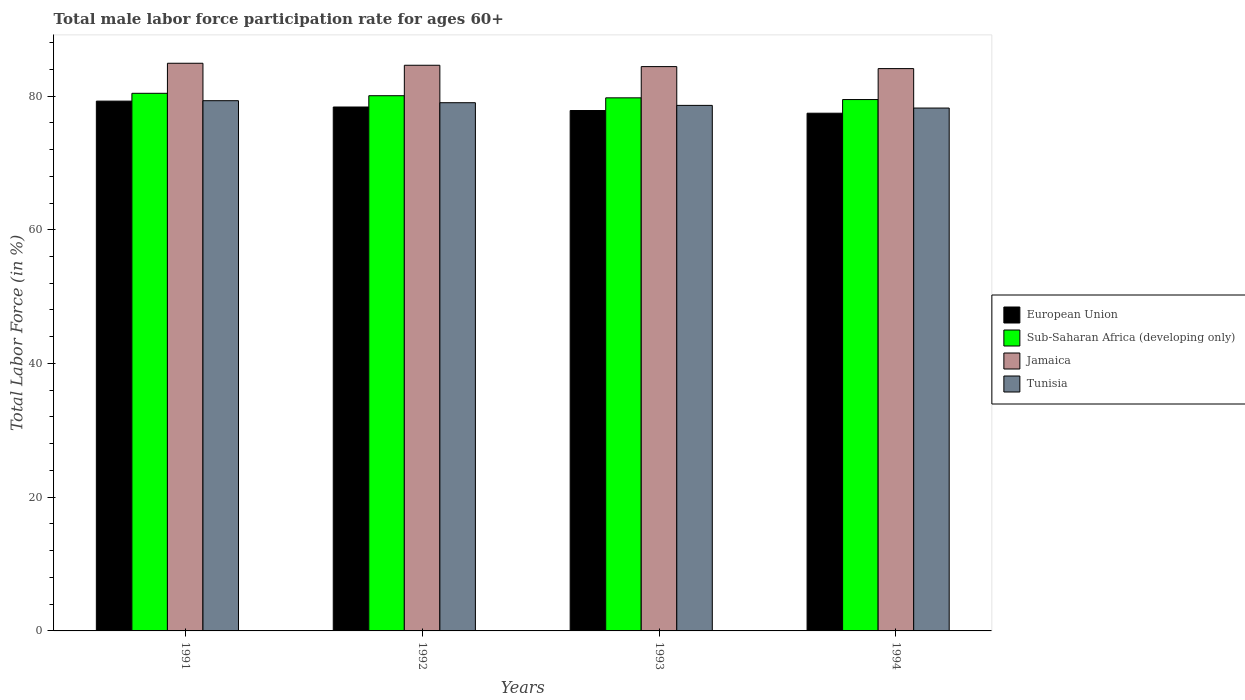How many different coloured bars are there?
Give a very brief answer. 4. Are the number of bars per tick equal to the number of legend labels?
Your answer should be very brief. Yes. How many bars are there on the 1st tick from the left?
Offer a very short reply. 4. How many bars are there on the 1st tick from the right?
Your answer should be compact. 4. What is the male labor force participation rate in Tunisia in 1994?
Give a very brief answer. 78.2. Across all years, what is the maximum male labor force participation rate in Jamaica?
Ensure brevity in your answer.  84.9. Across all years, what is the minimum male labor force participation rate in Jamaica?
Offer a very short reply. 84.1. What is the total male labor force participation rate in European Union in the graph?
Your answer should be compact. 312.85. What is the difference between the male labor force participation rate in Sub-Saharan Africa (developing only) in 1991 and that in 1992?
Offer a terse response. 0.36. What is the difference between the male labor force participation rate in Jamaica in 1993 and the male labor force participation rate in Sub-Saharan Africa (developing only) in 1991?
Your response must be concise. 3.99. What is the average male labor force participation rate in Sub-Saharan Africa (developing only) per year?
Provide a short and direct response. 79.91. In the year 1991, what is the difference between the male labor force participation rate in Tunisia and male labor force participation rate in European Union?
Make the answer very short. 0.06. What is the ratio of the male labor force participation rate in Sub-Saharan Africa (developing only) in 1992 to that in 1993?
Keep it short and to the point. 1. What is the difference between the highest and the second highest male labor force participation rate in Sub-Saharan Africa (developing only)?
Give a very brief answer. 0.36. What is the difference between the highest and the lowest male labor force participation rate in European Union?
Offer a terse response. 1.81. In how many years, is the male labor force participation rate in Tunisia greater than the average male labor force participation rate in Tunisia taken over all years?
Give a very brief answer. 2. What does the 1st bar from the left in 1993 represents?
Your response must be concise. European Union. What does the 1st bar from the right in 1994 represents?
Provide a succinct answer. Tunisia. Is it the case that in every year, the sum of the male labor force participation rate in Tunisia and male labor force participation rate in Jamaica is greater than the male labor force participation rate in European Union?
Provide a succinct answer. Yes. How many bars are there?
Keep it short and to the point. 16. Are all the bars in the graph horizontal?
Your answer should be compact. No. How many years are there in the graph?
Give a very brief answer. 4. Are the values on the major ticks of Y-axis written in scientific E-notation?
Give a very brief answer. No. Does the graph contain any zero values?
Your response must be concise. No. Does the graph contain grids?
Your answer should be compact. No. How many legend labels are there?
Your response must be concise. 4. What is the title of the graph?
Offer a terse response. Total male labor force participation rate for ages 60+. Does "Pacific island small states" appear as one of the legend labels in the graph?
Ensure brevity in your answer.  No. What is the Total Labor Force (in %) of European Union in 1991?
Offer a very short reply. 79.24. What is the Total Labor Force (in %) of Sub-Saharan Africa (developing only) in 1991?
Your answer should be compact. 80.41. What is the Total Labor Force (in %) in Jamaica in 1991?
Keep it short and to the point. 84.9. What is the Total Labor Force (in %) of Tunisia in 1991?
Give a very brief answer. 79.3. What is the Total Labor Force (in %) in European Union in 1992?
Offer a very short reply. 78.36. What is the Total Labor Force (in %) of Sub-Saharan Africa (developing only) in 1992?
Your answer should be compact. 80.05. What is the Total Labor Force (in %) of Jamaica in 1992?
Provide a short and direct response. 84.6. What is the Total Labor Force (in %) in Tunisia in 1992?
Offer a terse response. 79. What is the Total Labor Force (in %) of European Union in 1993?
Give a very brief answer. 77.83. What is the Total Labor Force (in %) in Sub-Saharan Africa (developing only) in 1993?
Make the answer very short. 79.73. What is the Total Labor Force (in %) in Jamaica in 1993?
Your response must be concise. 84.4. What is the Total Labor Force (in %) of Tunisia in 1993?
Provide a short and direct response. 78.6. What is the Total Labor Force (in %) in European Union in 1994?
Offer a terse response. 77.43. What is the Total Labor Force (in %) in Sub-Saharan Africa (developing only) in 1994?
Ensure brevity in your answer.  79.47. What is the Total Labor Force (in %) in Jamaica in 1994?
Your response must be concise. 84.1. What is the Total Labor Force (in %) in Tunisia in 1994?
Offer a very short reply. 78.2. Across all years, what is the maximum Total Labor Force (in %) of European Union?
Provide a succinct answer. 79.24. Across all years, what is the maximum Total Labor Force (in %) of Sub-Saharan Africa (developing only)?
Make the answer very short. 80.41. Across all years, what is the maximum Total Labor Force (in %) in Jamaica?
Keep it short and to the point. 84.9. Across all years, what is the maximum Total Labor Force (in %) of Tunisia?
Provide a succinct answer. 79.3. Across all years, what is the minimum Total Labor Force (in %) of European Union?
Make the answer very short. 77.43. Across all years, what is the minimum Total Labor Force (in %) in Sub-Saharan Africa (developing only)?
Your answer should be compact. 79.47. Across all years, what is the minimum Total Labor Force (in %) in Jamaica?
Provide a short and direct response. 84.1. Across all years, what is the minimum Total Labor Force (in %) of Tunisia?
Provide a succinct answer. 78.2. What is the total Total Labor Force (in %) of European Union in the graph?
Your answer should be very brief. 312.85. What is the total Total Labor Force (in %) of Sub-Saharan Africa (developing only) in the graph?
Ensure brevity in your answer.  319.65. What is the total Total Labor Force (in %) of Jamaica in the graph?
Make the answer very short. 338. What is the total Total Labor Force (in %) of Tunisia in the graph?
Your answer should be compact. 315.1. What is the difference between the Total Labor Force (in %) of European Union in 1991 and that in 1992?
Your answer should be very brief. 0.88. What is the difference between the Total Labor Force (in %) in Sub-Saharan Africa (developing only) in 1991 and that in 1992?
Give a very brief answer. 0.36. What is the difference between the Total Labor Force (in %) of Jamaica in 1991 and that in 1992?
Offer a very short reply. 0.3. What is the difference between the Total Labor Force (in %) of Tunisia in 1991 and that in 1992?
Offer a terse response. 0.3. What is the difference between the Total Labor Force (in %) of European Union in 1991 and that in 1993?
Your response must be concise. 1.41. What is the difference between the Total Labor Force (in %) of Sub-Saharan Africa (developing only) in 1991 and that in 1993?
Offer a very short reply. 0.68. What is the difference between the Total Labor Force (in %) in Jamaica in 1991 and that in 1993?
Ensure brevity in your answer.  0.5. What is the difference between the Total Labor Force (in %) of Tunisia in 1991 and that in 1993?
Give a very brief answer. 0.7. What is the difference between the Total Labor Force (in %) in European Union in 1991 and that in 1994?
Give a very brief answer. 1.81. What is the difference between the Total Labor Force (in %) in Sub-Saharan Africa (developing only) in 1991 and that in 1994?
Your response must be concise. 0.93. What is the difference between the Total Labor Force (in %) in Jamaica in 1991 and that in 1994?
Your answer should be compact. 0.8. What is the difference between the Total Labor Force (in %) in Tunisia in 1991 and that in 1994?
Your answer should be very brief. 1.1. What is the difference between the Total Labor Force (in %) of European Union in 1992 and that in 1993?
Provide a succinct answer. 0.53. What is the difference between the Total Labor Force (in %) of Sub-Saharan Africa (developing only) in 1992 and that in 1993?
Make the answer very short. 0.32. What is the difference between the Total Labor Force (in %) of Tunisia in 1992 and that in 1993?
Ensure brevity in your answer.  0.4. What is the difference between the Total Labor Force (in %) of European Union in 1992 and that in 1994?
Your answer should be compact. 0.93. What is the difference between the Total Labor Force (in %) in Sub-Saharan Africa (developing only) in 1992 and that in 1994?
Make the answer very short. 0.58. What is the difference between the Total Labor Force (in %) in Jamaica in 1992 and that in 1994?
Provide a short and direct response. 0.5. What is the difference between the Total Labor Force (in %) in European Union in 1993 and that in 1994?
Provide a succinct answer. 0.4. What is the difference between the Total Labor Force (in %) of Sub-Saharan Africa (developing only) in 1993 and that in 1994?
Offer a very short reply. 0.26. What is the difference between the Total Labor Force (in %) in Jamaica in 1993 and that in 1994?
Your response must be concise. 0.3. What is the difference between the Total Labor Force (in %) of Tunisia in 1993 and that in 1994?
Offer a terse response. 0.4. What is the difference between the Total Labor Force (in %) in European Union in 1991 and the Total Labor Force (in %) in Sub-Saharan Africa (developing only) in 1992?
Your response must be concise. -0.81. What is the difference between the Total Labor Force (in %) in European Union in 1991 and the Total Labor Force (in %) in Jamaica in 1992?
Keep it short and to the point. -5.36. What is the difference between the Total Labor Force (in %) of European Union in 1991 and the Total Labor Force (in %) of Tunisia in 1992?
Your answer should be very brief. 0.24. What is the difference between the Total Labor Force (in %) of Sub-Saharan Africa (developing only) in 1991 and the Total Labor Force (in %) of Jamaica in 1992?
Ensure brevity in your answer.  -4.19. What is the difference between the Total Labor Force (in %) in Sub-Saharan Africa (developing only) in 1991 and the Total Labor Force (in %) in Tunisia in 1992?
Your answer should be compact. 1.41. What is the difference between the Total Labor Force (in %) of European Union in 1991 and the Total Labor Force (in %) of Sub-Saharan Africa (developing only) in 1993?
Provide a succinct answer. -0.49. What is the difference between the Total Labor Force (in %) of European Union in 1991 and the Total Labor Force (in %) of Jamaica in 1993?
Offer a terse response. -5.16. What is the difference between the Total Labor Force (in %) of European Union in 1991 and the Total Labor Force (in %) of Tunisia in 1993?
Make the answer very short. 0.64. What is the difference between the Total Labor Force (in %) of Sub-Saharan Africa (developing only) in 1991 and the Total Labor Force (in %) of Jamaica in 1993?
Make the answer very short. -3.99. What is the difference between the Total Labor Force (in %) in Sub-Saharan Africa (developing only) in 1991 and the Total Labor Force (in %) in Tunisia in 1993?
Offer a terse response. 1.81. What is the difference between the Total Labor Force (in %) of European Union in 1991 and the Total Labor Force (in %) of Sub-Saharan Africa (developing only) in 1994?
Make the answer very short. -0.23. What is the difference between the Total Labor Force (in %) of European Union in 1991 and the Total Labor Force (in %) of Jamaica in 1994?
Your response must be concise. -4.86. What is the difference between the Total Labor Force (in %) of European Union in 1991 and the Total Labor Force (in %) of Tunisia in 1994?
Provide a short and direct response. 1.04. What is the difference between the Total Labor Force (in %) in Sub-Saharan Africa (developing only) in 1991 and the Total Labor Force (in %) in Jamaica in 1994?
Your answer should be compact. -3.69. What is the difference between the Total Labor Force (in %) in Sub-Saharan Africa (developing only) in 1991 and the Total Labor Force (in %) in Tunisia in 1994?
Your answer should be compact. 2.21. What is the difference between the Total Labor Force (in %) of European Union in 1992 and the Total Labor Force (in %) of Sub-Saharan Africa (developing only) in 1993?
Give a very brief answer. -1.37. What is the difference between the Total Labor Force (in %) in European Union in 1992 and the Total Labor Force (in %) in Jamaica in 1993?
Offer a very short reply. -6.04. What is the difference between the Total Labor Force (in %) in European Union in 1992 and the Total Labor Force (in %) in Tunisia in 1993?
Your response must be concise. -0.24. What is the difference between the Total Labor Force (in %) of Sub-Saharan Africa (developing only) in 1992 and the Total Labor Force (in %) of Jamaica in 1993?
Your answer should be very brief. -4.35. What is the difference between the Total Labor Force (in %) in Sub-Saharan Africa (developing only) in 1992 and the Total Labor Force (in %) in Tunisia in 1993?
Keep it short and to the point. 1.45. What is the difference between the Total Labor Force (in %) of Jamaica in 1992 and the Total Labor Force (in %) of Tunisia in 1993?
Provide a short and direct response. 6. What is the difference between the Total Labor Force (in %) in European Union in 1992 and the Total Labor Force (in %) in Sub-Saharan Africa (developing only) in 1994?
Give a very brief answer. -1.11. What is the difference between the Total Labor Force (in %) of European Union in 1992 and the Total Labor Force (in %) of Jamaica in 1994?
Your response must be concise. -5.74. What is the difference between the Total Labor Force (in %) in European Union in 1992 and the Total Labor Force (in %) in Tunisia in 1994?
Your answer should be very brief. 0.16. What is the difference between the Total Labor Force (in %) in Sub-Saharan Africa (developing only) in 1992 and the Total Labor Force (in %) in Jamaica in 1994?
Provide a succinct answer. -4.05. What is the difference between the Total Labor Force (in %) in Sub-Saharan Africa (developing only) in 1992 and the Total Labor Force (in %) in Tunisia in 1994?
Ensure brevity in your answer.  1.85. What is the difference between the Total Labor Force (in %) in Jamaica in 1992 and the Total Labor Force (in %) in Tunisia in 1994?
Provide a succinct answer. 6.4. What is the difference between the Total Labor Force (in %) in European Union in 1993 and the Total Labor Force (in %) in Sub-Saharan Africa (developing only) in 1994?
Keep it short and to the point. -1.64. What is the difference between the Total Labor Force (in %) in European Union in 1993 and the Total Labor Force (in %) in Jamaica in 1994?
Give a very brief answer. -6.27. What is the difference between the Total Labor Force (in %) of European Union in 1993 and the Total Labor Force (in %) of Tunisia in 1994?
Provide a short and direct response. -0.37. What is the difference between the Total Labor Force (in %) in Sub-Saharan Africa (developing only) in 1993 and the Total Labor Force (in %) in Jamaica in 1994?
Give a very brief answer. -4.37. What is the difference between the Total Labor Force (in %) of Sub-Saharan Africa (developing only) in 1993 and the Total Labor Force (in %) of Tunisia in 1994?
Your answer should be compact. 1.53. What is the difference between the Total Labor Force (in %) in Jamaica in 1993 and the Total Labor Force (in %) in Tunisia in 1994?
Offer a very short reply. 6.2. What is the average Total Labor Force (in %) of European Union per year?
Your answer should be very brief. 78.21. What is the average Total Labor Force (in %) of Sub-Saharan Africa (developing only) per year?
Offer a terse response. 79.91. What is the average Total Labor Force (in %) of Jamaica per year?
Ensure brevity in your answer.  84.5. What is the average Total Labor Force (in %) of Tunisia per year?
Provide a short and direct response. 78.78. In the year 1991, what is the difference between the Total Labor Force (in %) of European Union and Total Labor Force (in %) of Sub-Saharan Africa (developing only)?
Your answer should be very brief. -1.17. In the year 1991, what is the difference between the Total Labor Force (in %) of European Union and Total Labor Force (in %) of Jamaica?
Provide a succinct answer. -5.66. In the year 1991, what is the difference between the Total Labor Force (in %) in European Union and Total Labor Force (in %) in Tunisia?
Your response must be concise. -0.06. In the year 1991, what is the difference between the Total Labor Force (in %) of Sub-Saharan Africa (developing only) and Total Labor Force (in %) of Jamaica?
Your answer should be compact. -4.49. In the year 1991, what is the difference between the Total Labor Force (in %) in Sub-Saharan Africa (developing only) and Total Labor Force (in %) in Tunisia?
Offer a terse response. 1.11. In the year 1991, what is the difference between the Total Labor Force (in %) in Jamaica and Total Labor Force (in %) in Tunisia?
Offer a very short reply. 5.6. In the year 1992, what is the difference between the Total Labor Force (in %) in European Union and Total Labor Force (in %) in Sub-Saharan Africa (developing only)?
Make the answer very short. -1.69. In the year 1992, what is the difference between the Total Labor Force (in %) of European Union and Total Labor Force (in %) of Jamaica?
Offer a very short reply. -6.24. In the year 1992, what is the difference between the Total Labor Force (in %) in European Union and Total Labor Force (in %) in Tunisia?
Your answer should be very brief. -0.64. In the year 1992, what is the difference between the Total Labor Force (in %) of Sub-Saharan Africa (developing only) and Total Labor Force (in %) of Jamaica?
Offer a very short reply. -4.55. In the year 1992, what is the difference between the Total Labor Force (in %) of Sub-Saharan Africa (developing only) and Total Labor Force (in %) of Tunisia?
Offer a terse response. 1.05. In the year 1992, what is the difference between the Total Labor Force (in %) in Jamaica and Total Labor Force (in %) in Tunisia?
Keep it short and to the point. 5.6. In the year 1993, what is the difference between the Total Labor Force (in %) in European Union and Total Labor Force (in %) in Sub-Saharan Africa (developing only)?
Provide a short and direct response. -1.9. In the year 1993, what is the difference between the Total Labor Force (in %) of European Union and Total Labor Force (in %) of Jamaica?
Offer a very short reply. -6.57. In the year 1993, what is the difference between the Total Labor Force (in %) of European Union and Total Labor Force (in %) of Tunisia?
Provide a succinct answer. -0.77. In the year 1993, what is the difference between the Total Labor Force (in %) in Sub-Saharan Africa (developing only) and Total Labor Force (in %) in Jamaica?
Provide a succinct answer. -4.67. In the year 1993, what is the difference between the Total Labor Force (in %) in Sub-Saharan Africa (developing only) and Total Labor Force (in %) in Tunisia?
Offer a very short reply. 1.13. In the year 1994, what is the difference between the Total Labor Force (in %) of European Union and Total Labor Force (in %) of Sub-Saharan Africa (developing only)?
Provide a succinct answer. -2.04. In the year 1994, what is the difference between the Total Labor Force (in %) of European Union and Total Labor Force (in %) of Jamaica?
Offer a terse response. -6.67. In the year 1994, what is the difference between the Total Labor Force (in %) of European Union and Total Labor Force (in %) of Tunisia?
Offer a very short reply. -0.77. In the year 1994, what is the difference between the Total Labor Force (in %) in Sub-Saharan Africa (developing only) and Total Labor Force (in %) in Jamaica?
Your response must be concise. -4.63. In the year 1994, what is the difference between the Total Labor Force (in %) in Sub-Saharan Africa (developing only) and Total Labor Force (in %) in Tunisia?
Your answer should be very brief. 1.27. What is the ratio of the Total Labor Force (in %) in European Union in 1991 to that in 1992?
Your response must be concise. 1.01. What is the ratio of the Total Labor Force (in %) in Sub-Saharan Africa (developing only) in 1991 to that in 1992?
Your response must be concise. 1. What is the ratio of the Total Labor Force (in %) in Jamaica in 1991 to that in 1992?
Your answer should be compact. 1. What is the ratio of the Total Labor Force (in %) of Tunisia in 1991 to that in 1992?
Give a very brief answer. 1. What is the ratio of the Total Labor Force (in %) of European Union in 1991 to that in 1993?
Your response must be concise. 1.02. What is the ratio of the Total Labor Force (in %) of Sub-Saharan Africa (developing only) in 1991 to that in 1993?
Keep it short and to the point. 1.01. What is the ratio of the Total Labor Force (in %) in Jamaica in 1991 to that in 1993?
Provide a succinct answer. 1.01. What is the ratio of the Total Labor Force (in %) in Tunisia in 1991 to that in 1993?
Keep it short and to the point. 1.01. What is the ratio of the Total Labor Force (in %) in European Union in 1991 to that in 1994?
Provide a succinct answer. 1.02. What is the ratio of the Total Labor Force (in %) of Sub-Saharan Africa (developing only) in 1991 to that in 1994?
Your answer should be very brief. 1.01. What is the ratio of the Total Labor Force (in %) of Jamaica in 1991 to that in 1994?
Provide a short and direct response. 1.01. What is the ratio of the Total Labor Force (in %) of Tunisia in 1991 to that in 1994?
Offer a very short reply. 1.01. What is the ratio of the Total Labor Force (in %) of European Union in 1992 to that in 1993?
Offer a terse response. 1.01. What is the ratio of the Total Labor Force (in %) in Sub-Saharan Africa (developing only) in 1992 to that in 1993?
Your answer should be compact. 1. What is the ratio of the Total Labor Force (in %) of Sub-Saharan Africa (developing only) in 1992 to that in 1994?
Your answer should be compact. 1.01. What is the ratio of the Total Labor Force (in %) in Jamaica in 1992 to that in 1994?
Make the answer very short. 1.01. What is the ratio of the Total Labor Force (in %) of Tunisia in 1992 to that in 1994?
Offer a terse response. 1.01. What is the ratio of the Total Labor Force (in %) in European Union in 1993 to that in 1994?
Ensure brevity in your answer.  1.01. What is the ratio of the Total Labor Force (in %) in Sub-Saharan Africa (developing only) in 1993 to that in 1994?
Your response must be concise. 1. What is the ratio of the Total Labor Force (in %) in Jamaica in 1993 to that in 1994?
Provide a short and direct response. 1. What is the difference between the highest and the second highest Total Labor Force (in %) of European Union?
Your answer should be compact. 0.88. What is the difference between the highest and the second highest Total Labor Force (in %) of Sub-Saharan Africa (developing only)?
Offer a very short reply. 0.36. What is the difference between the highest and the second highest Total Labor Force (in %) in Tunisia?
Your response must be concise. 0.3. What is the difference between the highest and the lowest Total Labor Force (in %) of European Union?
Ensure brevity in your answer.  1.81. What is the difference between the highest and the lowest Total Labor Force (in %) of Sub-Saharan Africa (developing only)?
Your answer should be compact. 0.93. What is the difference between the highest and the lowest Total Labor Force (in %) of Tunisia?
Offer a very short reply. 1.1. 